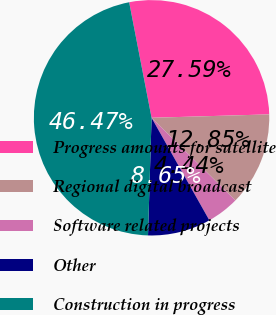<chart> <loc_0><loc_0><loc_500><loc_500><pie_chart><fcel>Progress amounts for satellite<fcel>Regional digital broadcast<fcel>Software related projects<fcel>Other<fcel>Construction in progress<nl><fcel>27.59%<fcel>12.85%<fcel>4.44%<fcel>8.65%<fcel>46.47%<nl></chart> 